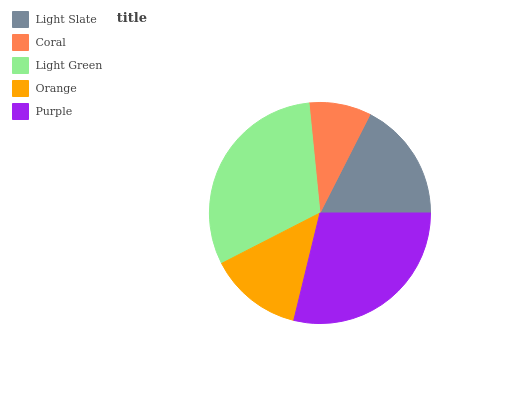Is Coral the minimum?
Answer yes or no. Yes. Is Light Green the maximum?
Answer yes or no. Yes. Is Light Green the minimum?
Answer yes or no. No. Is Coral the maximum?
Answer yes or no. No. Is Light Green greater than Coral?
Answer yes or no. Yes. Is Coral less than Light Green?
Answer yes or no. Yes. Is Coral greater than Light Green?
Answer yes or no. No. Is Light Green less than Coral?
Answer yes or no. No. Is Light Slate the high median?
Answer yes or no. Yes. Is Light Slate the low median?
Answer yes or no. Yes. Is Coral the high median?
Answer yes or no. No. Is Orange the low median?
Answer yes or no. No. 